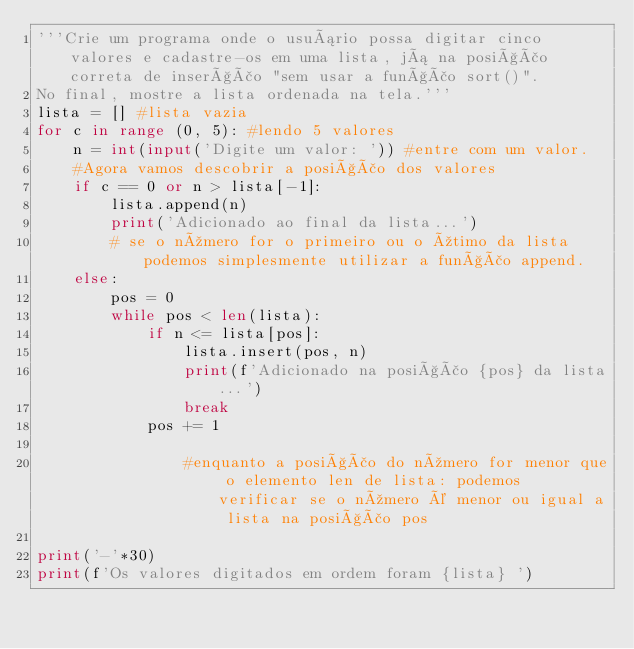<code> <loc_0><loc_0><loc_500><loc_500><_Python_>'''Crie um programa onde o usuário possa digitar cinco valores e cadastre-os em uma lista, já na posição correta de inserção "sem usar a função sort()".
No final, mostre a lista ordenada na tela.'''
lista = [] #lista vazia
for c in range (0, 5): #lendo 5 valores
    n = int(input('Digite um valor: ')) #entre com um valor.
    #Agora vamos descobrir a posição dos valores
    if c == 0 or n > lista[-1]:
        lista.append(n)
        print('Adicionado ao final da lista...')
        # se o número for o primeiro ou o útimo da lista podemos simplesmente utilizar a função append.
    else:
        pos = 0
        while pos < len(lista):
            if n <= lista[pos]:
                lista.insert(pos, n)
                print(f'Adicionado na posição {pos} da lista...')
                break
            pos += 1 

                #enquanto a posição do número for menor que o elemento len de lista: podemos verificar se o número é menor ou igual a lista na posição pos
            
print('-'*30)
print(f'Os valores digitados em ordem foram {lista} ')            

               


      </code> 